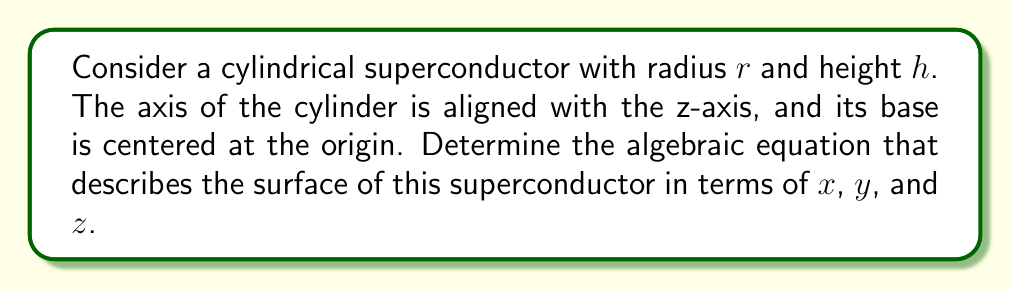Give your solution to this math problem. Let's approach this step-by-step:

1) First, we need to consider the equation of a circle in the xy-plane, as the cross-section of a cylinder is a circle:

   $$x^2 + y^2 = r^2$$

2) This equation holds true for any z-value within the height of the cylinder. So, we need to consider the range of z:

   $$0 \leq z \leq h$$

3) To combine these into a single equation, we can use the fact that for any point on the surface of the cylinder, either:
   a) It's on the circular base or top (z = 0 or z = h), or
   b) It's on the curved surface (x^2 + y^2 = r^2)

4) We can express this mathematically using the following equation:

   $$(x^2 + y^2 - r^2)(z)(z-h) = 0$$

5) This equation is satisfied when:
   - $x^2 + y^2 - r^2 = 0$ (points on the curved surface)
   - $z = 0$ (points on the bottom circular base)
   - $z = h$ (points on the top circular base)

6) This single equation describes all points on the surface of the cylindrical superconductor.

[asy]
import three;
size(200);
currentprojection=perspective(6,3,2);
real r=1, h=2;
draw(surface(cylinder((0,0,0),r,h)),paleblue);
draw(circle((0,0,0),r),blue);
draw(circle((0,0,h),r),blue);
draw((0,0,0)--(0,0,h),dashed);
label("r",(r/2,0,0),E);
label("h",(0,0,h/2),W);
[/asy]
Answer: $$(x^2 + y^2 - r^2)(z)(z-h) = 0$$ 